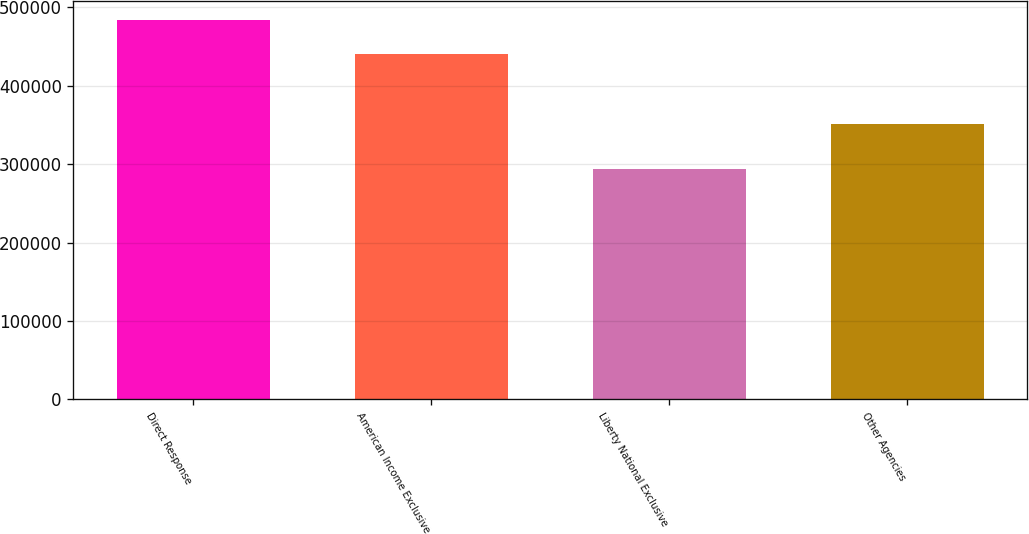Convert chart to OTSL. <chart><loc_0><loc_0><loc_500><loc_500><bar_chart><fcel>Direct Response<fcel>American Income Exclusive<fcel>Liberty National Exclusive<fcel>Other Agencies<nl><fcel>484176<fcel>440164<fcel>293936<fcel>351688<nl></chart> 